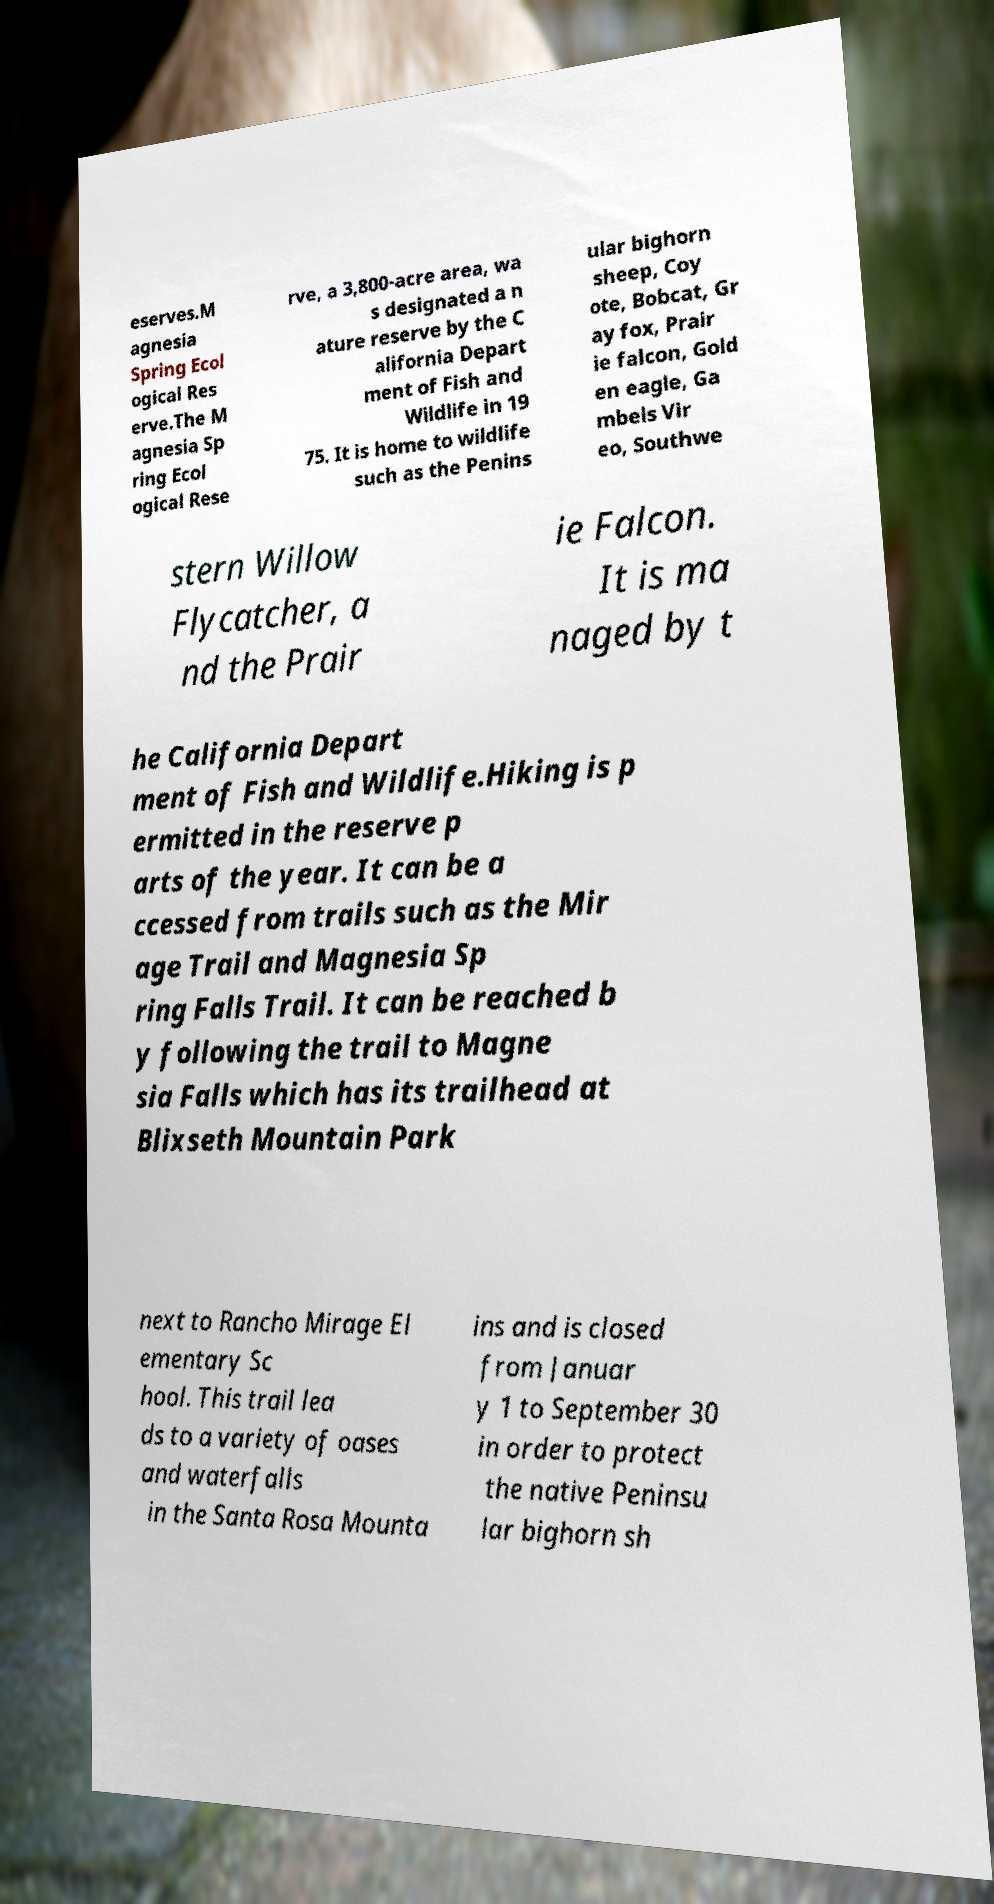There's text embedded in this image that I need extracted. Can you transcribe it verbatim? eserves.M agnesia Spring Ecol ogical Res erve.The M agnesia Sp ring Ecol ogical Rese rve, a 3,800-acre area, wa s designated a n ature reserve by the C alifornia Depart ment of Fish and Wildlife in 19 75. It is home to wildlife such as the Penins ular bighorn sheep, Coy ote, Bobcat, Gr ay fox, Prair ie falcon, Gold en eagle, Ga mbels Vir eo, Southwe stern Willow Flycatcher, a nd the Prair ie Falcon. It is ma naged by t he California Depart ment of Fish and Wildlife.Hiking is p ermitted in the reserve p arts of the year. It can be a ccessed from trails such as the Mir age Trail and Magnesia Sp ring Falls Trail. It can be reached b y following the trail to Magne sia Falls which has its trailhead at Blixseth Mountain Park next to Rancho Mirage El ementary Sc hool. This trail lea ds to a variety of oases and waterfalls in the Santa Rosa Mounta ins and is closed from Januar y 1 to September 30 in order to protect the native Peninsu lar bighorn sh 